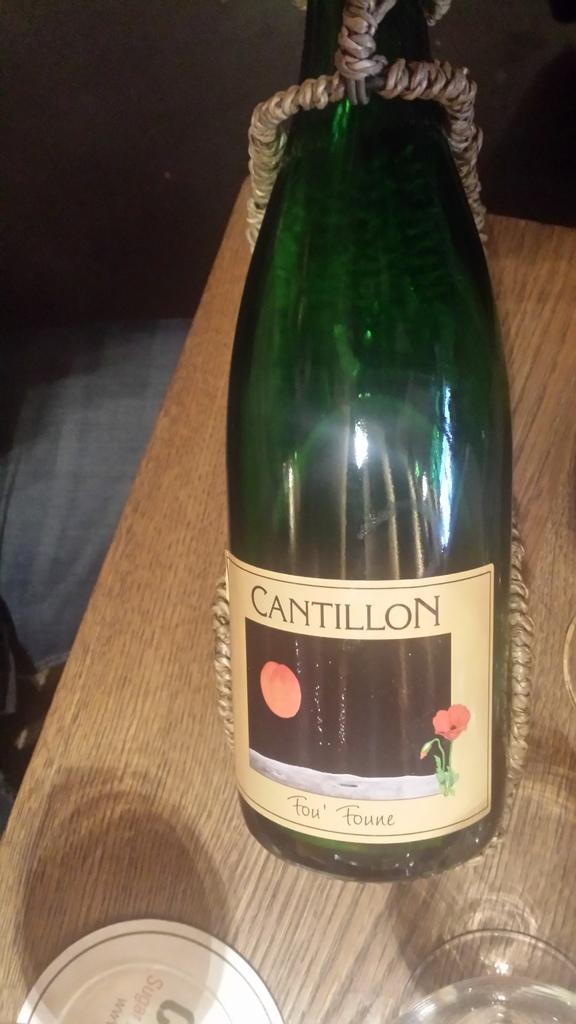What is the main object in the image? There is a wine bottle in the image. How is the wine bottle secured or attached? The wine bottle is tied with a rope. Where is the wine bottle located? The wine bottle is on a table. How many trees can be seen in the image? There are no trees visible in the image; it only features a wine bottle tied with a rope and located on a table. 